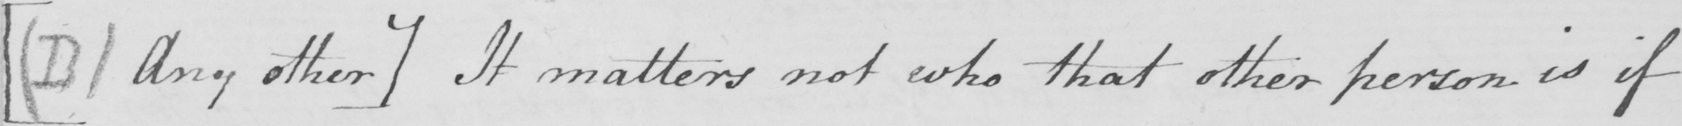Transcribe the text shown in this historical manuscript line. [  ( B )  Any other ]  It matters not who that other person is if 